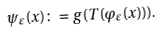Convert formula to latex. <formula><loc_0><loc_0><loc_500><loc_500>\psi _ { \varepsilon } ( x ) \colon = g ( T ( \varphi _ { \varepsilon } ( x ) ) ) .</formula> 